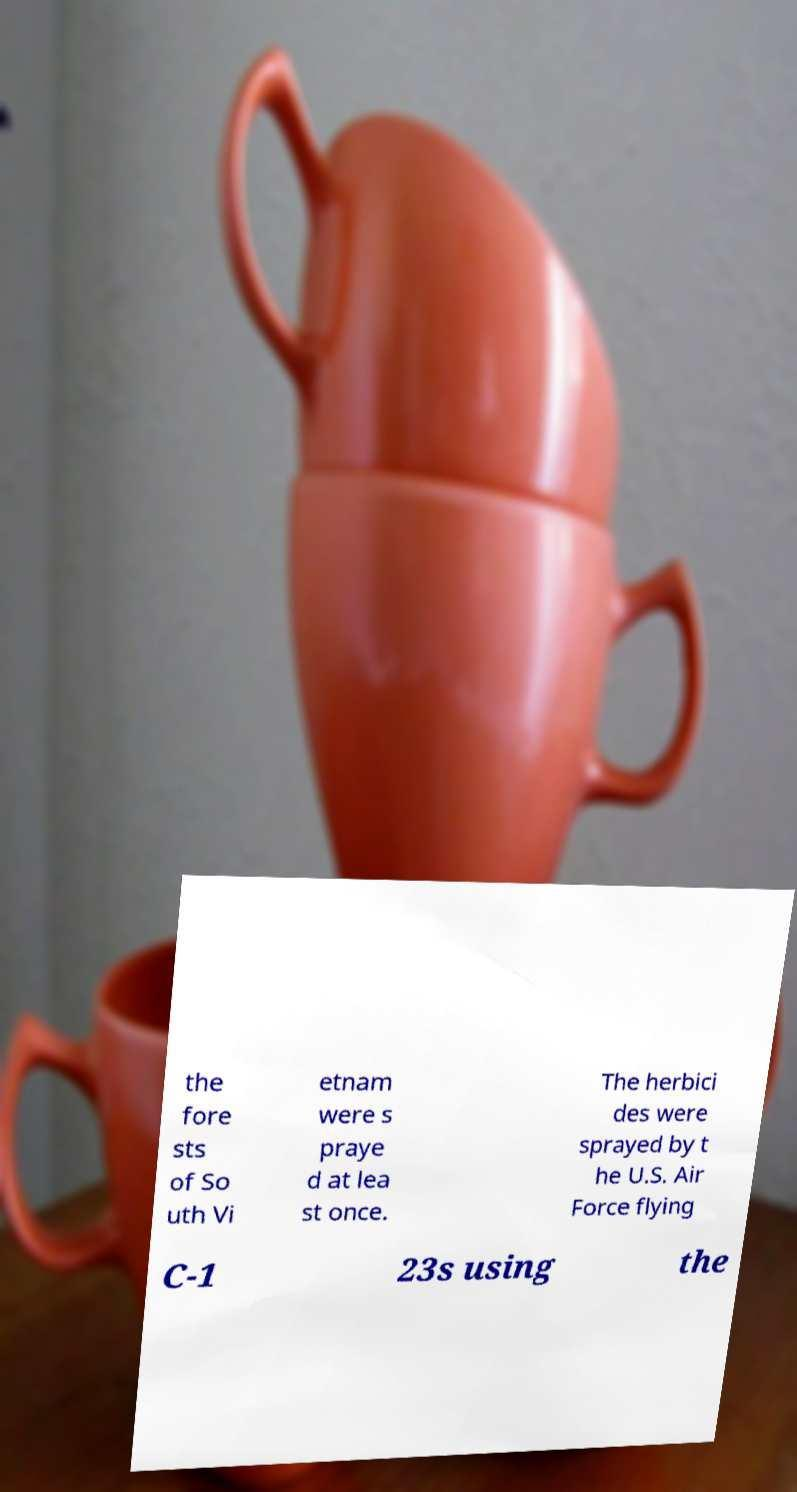Please read and relay the text visible in this image. What does it say? the fore sts of So uth Vi etnam were s praye d at lea st once. The herbici des were sprayed by t he U.S. Air Force flying C-1 23s using the 